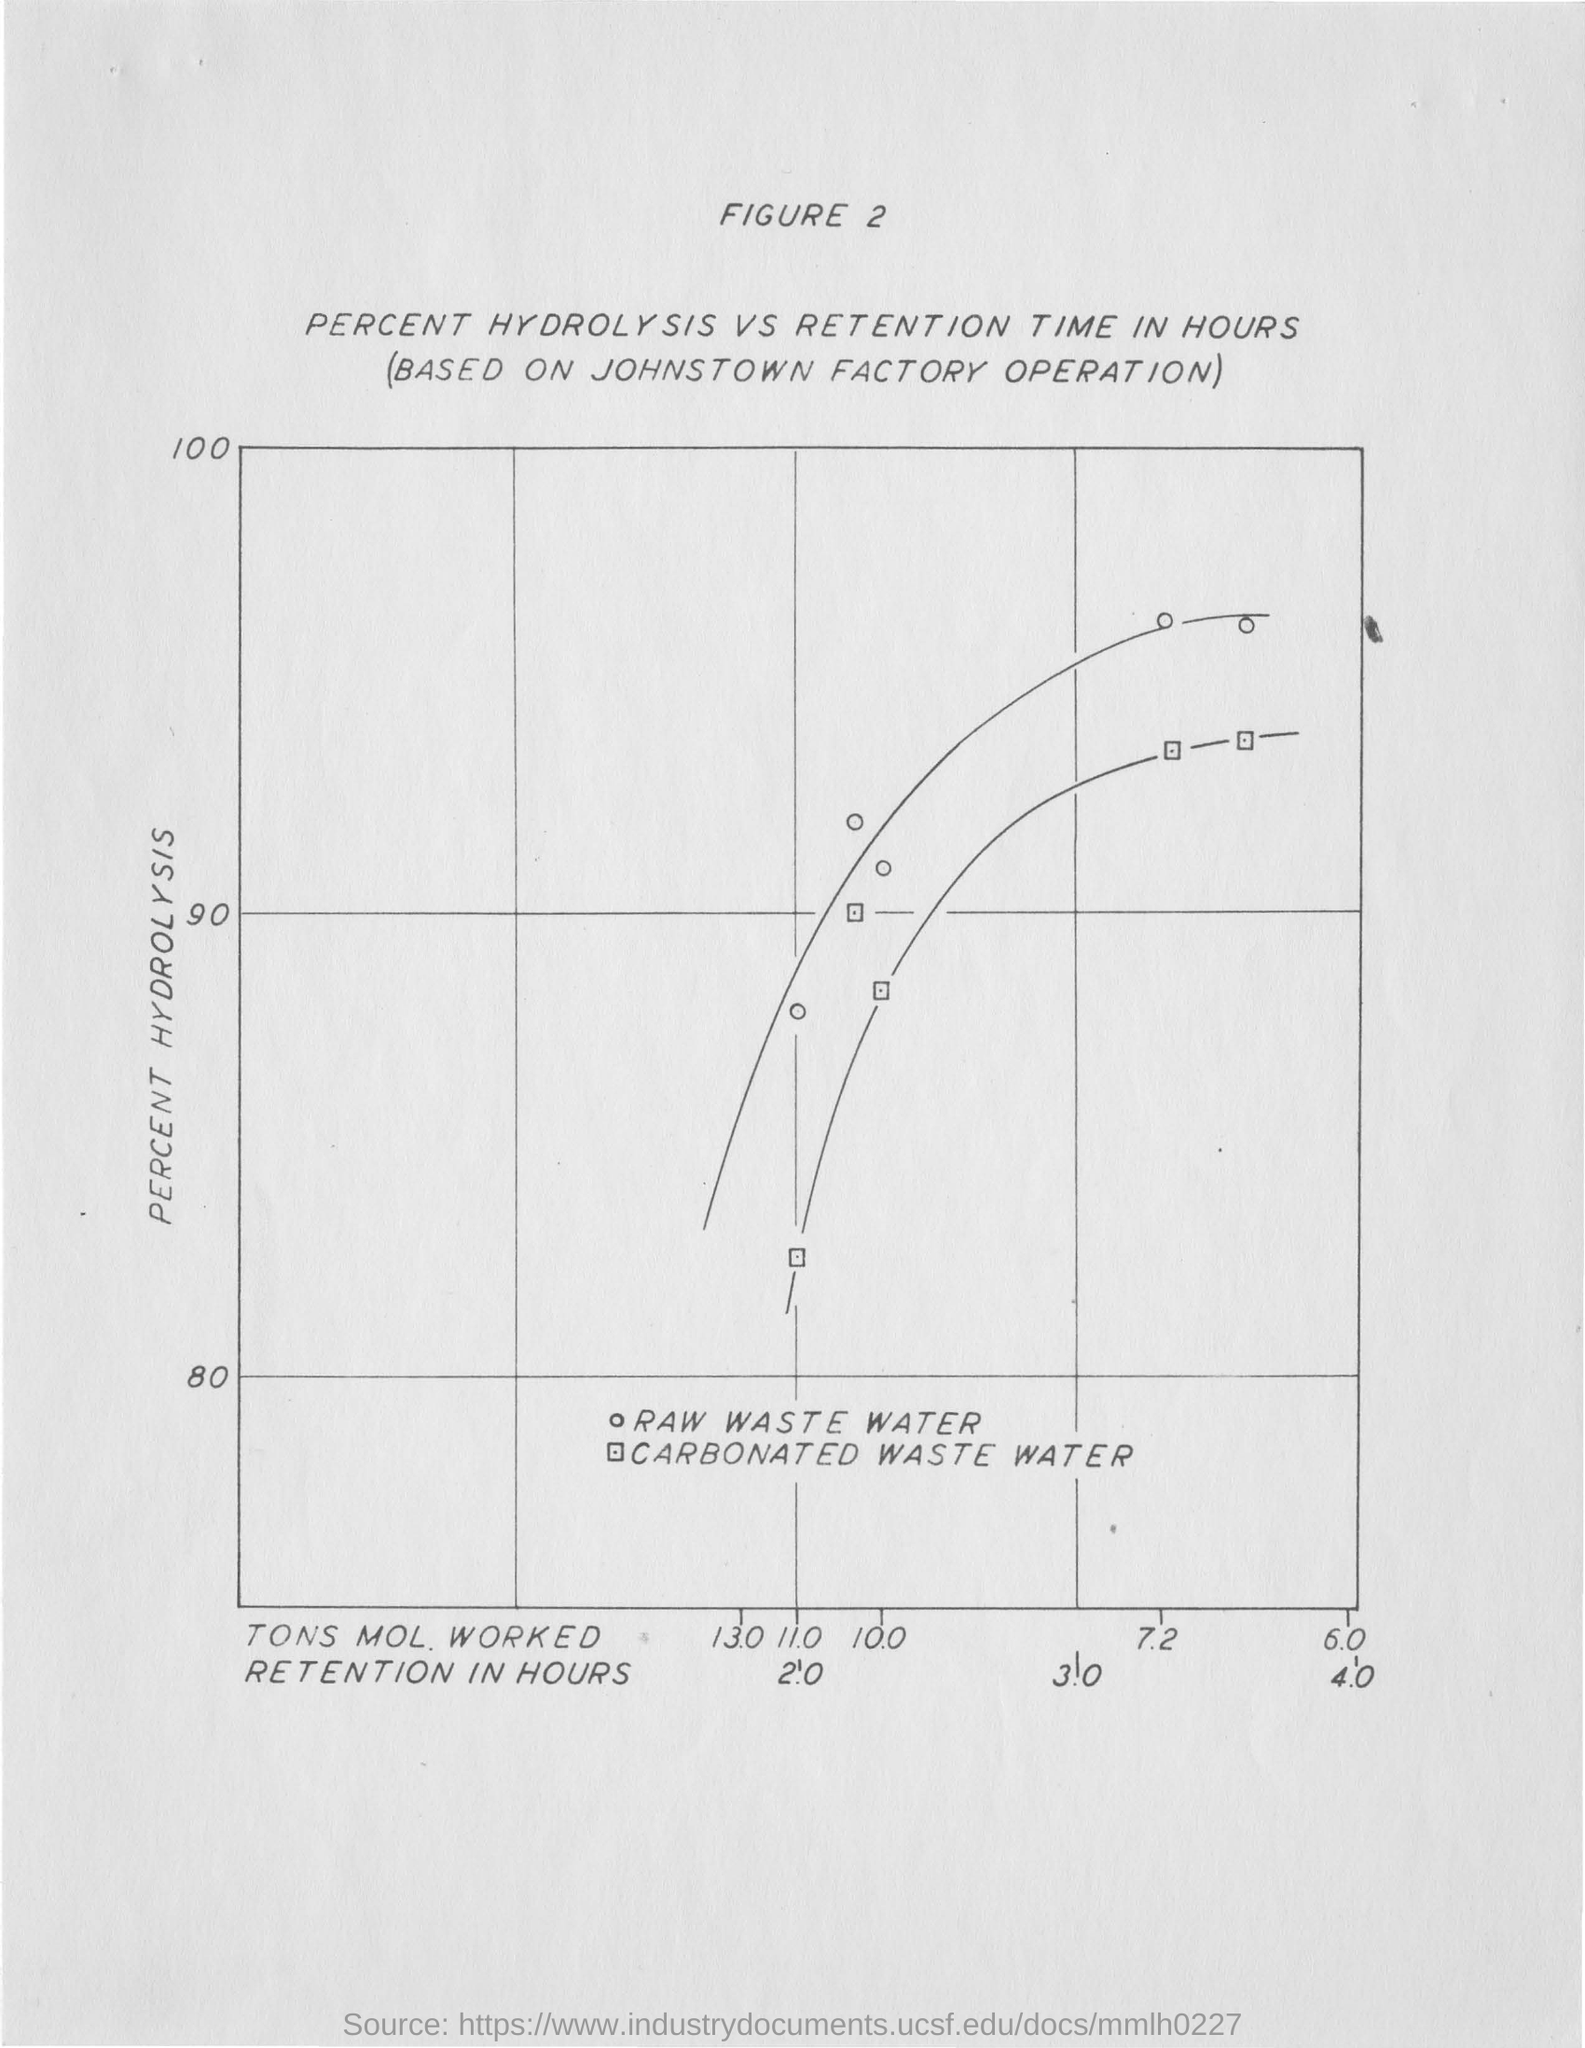What is plotted in the y-axis?
Keep it short and to the point. Percent hydrolysis. 